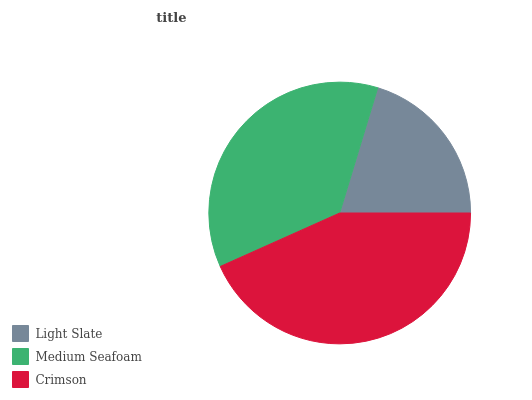Is Light Slate the minimum?
Answer yes or no. Yes. Is Crimson the maximum?
Answer yes or no. Yes. Is Medium Seafoam the minimum?
Answer yes or no. No. Is Medium Seafoam the maximum?
Answer yes or no. No. Is Medium Seafoam greater than Light Slate?
Answer yes or no. Yes. Is Light Slate less than Medium Seafoam?
Answer yes or no. Yes. Is Light Slate greater than Medium Seafoam?
Answer yes or no. No. Is Medium Seafoam less than Light Slate?
Answer yes or no. No. Is Medium Seafoam the high median?
Answer yes or no. Yes. Is Medium Seafoam the low median?
Answer yes or no. Yes. Is Crimson the high median?
Answer yes or no. No. Is Light Slate the low median?
Answer yes or no. No. 